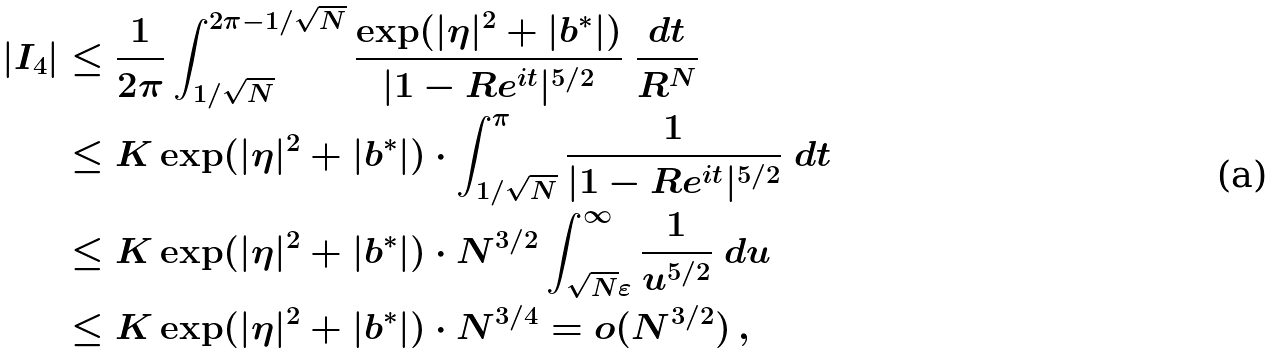Convert formula to latex. <formula><loc_0><loc_0><loc_500><loc_500>| I _ { 4 } | & \leq \frac { 1 } { 2 \pi } \int _ { 1 / \sqrt { N } } ^ { 2 \pi - 1 / \sqrt { N } } \frac { \exp ( | \eta | ^ { 2 } + | b ^ { * } | ) } { | 1 - R e ^ { i t } | ^ { 5 / 2 } } \ \frac { d t } { R ^ { N } } \\ & \leq K \exp ( | \eta | ^ { 2 } + | b ^ { * } | ) \cdot \int _ { 1 / \sqrt { N } } ^ { \pi } \frac { 1 } { | 1 - R e ^ { i t } | ^ { 5 / 2 } } \ d t \\ & \leq K \exp ( | \eta | ^ { 2 } + | b ^ { * } | ) \cdot N ^ { 3 / 2 } \int _ { \sqrt { N } \varepsilon } ^ { \infty } \frac { 1 } { u ^ { 5 / 2 } } \ d u \\ & \leq K \exp ( | \eta | ^ { 2 } + | b ^ { * } | ) \cdot N ^ { 3 / 4 } = o ( N ^ { 3 / 2 } ) \, ,</formula> 